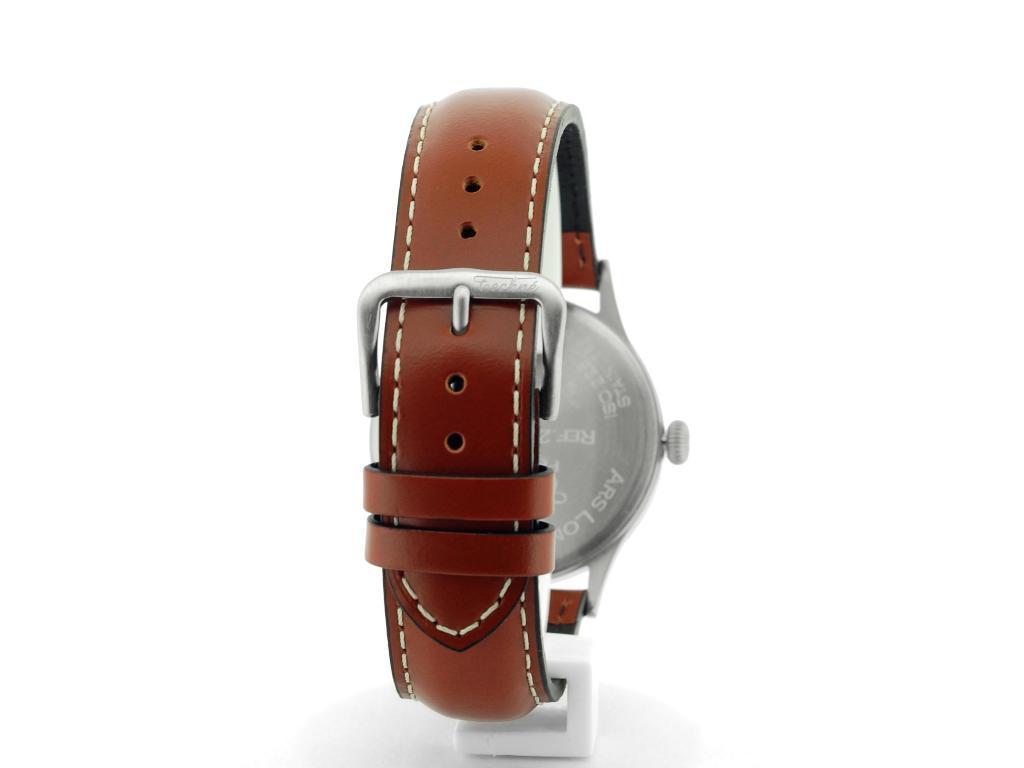Could you give a brief overview of what you see in this image? In this image we can see a watch on a platform. In the background the image is white in color. 